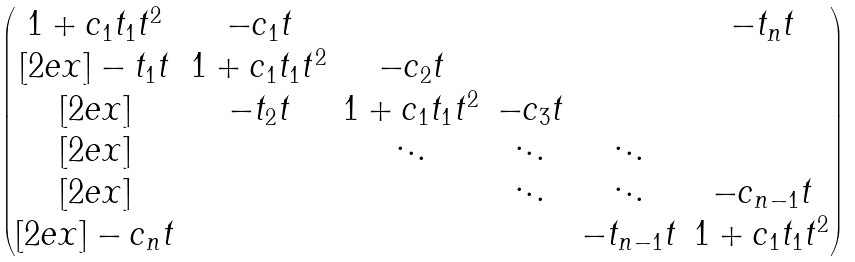Convert formula to latex. <formula><loc_0><loc_0><loc_500><loc_500>\begin{pmatrix} 1 + c _ { 1 } t _ { 1 } t ^ { 2 } & - c _ { 1 } t & & & & - t _ { n } t \\ [ 2 e x ] - t _ { 1 } t & 1 + c _ { 1 } t _ { 1 } t ^ { 2 } & - c _ { 2 } t & & & \\ [ 2 e x ] & - t _ { 2 } t & 1 + c _ { 1 } t _ { 1 } t ^ { 2 } & - c _ { 3 } t & & \\ [ 2 e x ] & & \ddots & \ddots & \ddots & \\ [ 2 e x ] & & & \ddots & \ddots & - c _ { n - 1 } t \\ [ 2 e x ] - c _ { n } t & & & & - t _ { n - 1 } t & 1 + c _ { 1 } t _ { 1 } t ^ { 2 } \end{pmatrix}</formula> 